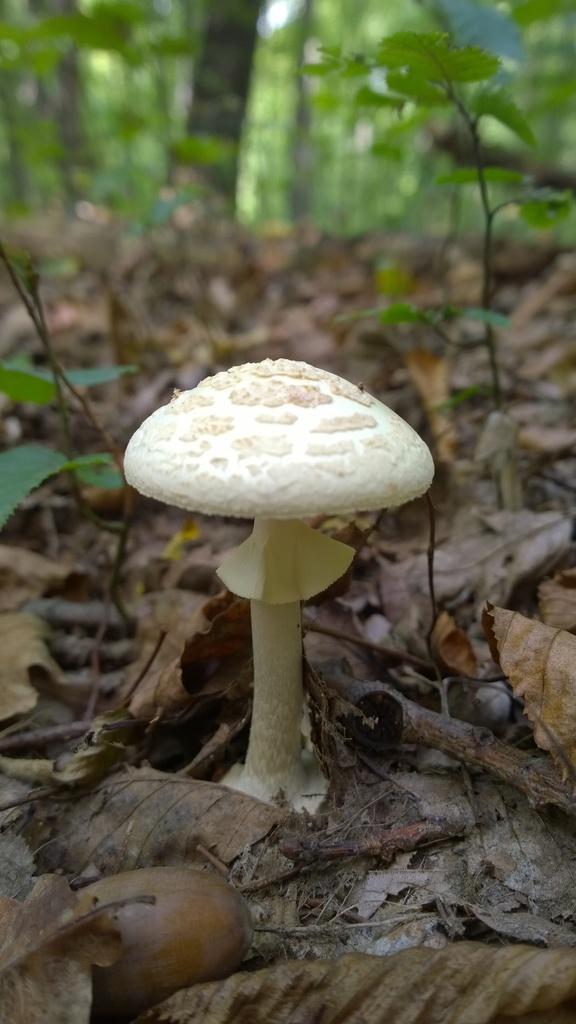Please provide a concise description of this image. In this image we can see one white mushroom on the ground, some dried leaves on the ground, one round object on the ground looks like a stone, some trees, some plants and some dried sticks on the ground. 